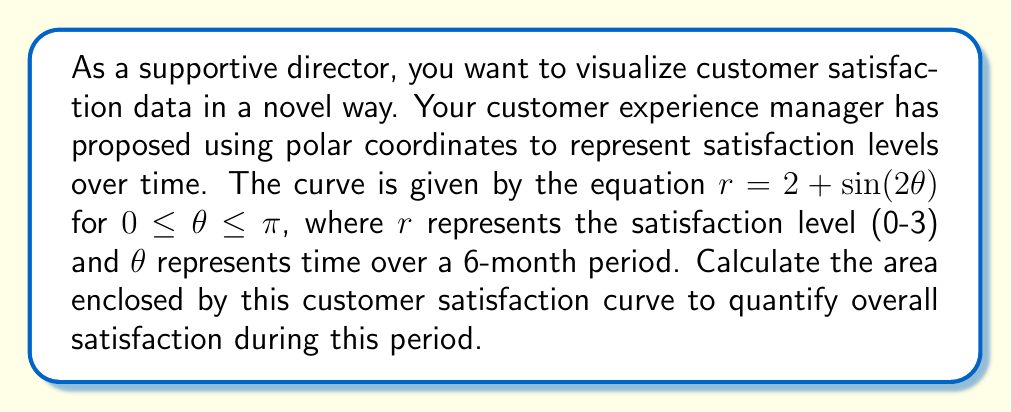What is the answer to this math problem? To calculate the area enclosed by the curve in polar coordinates, we use the formula:

$$A = \frac{1}{2} \int_a^b r^2(\theta) d\theta$$

Where $r(\theta) = 2 + \sin(2\theta)$ and the limits are from $0$ to $\pi$.

Step 1: Square the function $r(\theta)$
$$r^2(\theta) = (2 + \sin(2\theta))^2 = 4 + 4\sin(2\theta) + \sin^2(2\theta)$$

Step 2: Set up the integral
$$A = \frac{1}{2} \int_0^\pi (4 + 4\sin(2\theta) + \sin^2(2\theta)) d\theta$$

Step 3: Integrate each term
- $\int_0^\pi 4 d\theta = 4\theta \big|_0^\pi = 4\pi$
- $\int_0^\pi 4\sin(2\theta) d\theta = -2\cos(2\theta) \big|_0^\pi = 0$
- For $\int_0^\pi \sin^2(2\theta) d\theta$, use the identity $\sin^2(x) = \frac{1}{2}(1 - \cos(2x))$:
  $$\int_0^\pi \sin^2(2\theta) d\theta = \int_0^\pi \frac{1}{2}(1 - \cos(4\theta)) d\theta = \frac{1}{2}\theta - \frac{1}{8}\sin(4\theta) \big|_0^\pi = \frac{\pi}{2}$$

Step 4: Sum up the results and multiply by $\frac{1}{2}$
$$A = \frac{1}{2}(4\pi + 0 + \frac{\pi}{2}) = 2\pi + \frac{\pi}{4} = \frac{9\pi}{4}$$

Therefore, the area enclosed by the customer satisfaction curve is $\frac{9\pi}{4}$ square units.
Answer: $\frac{9\pi}{4}$ square units 